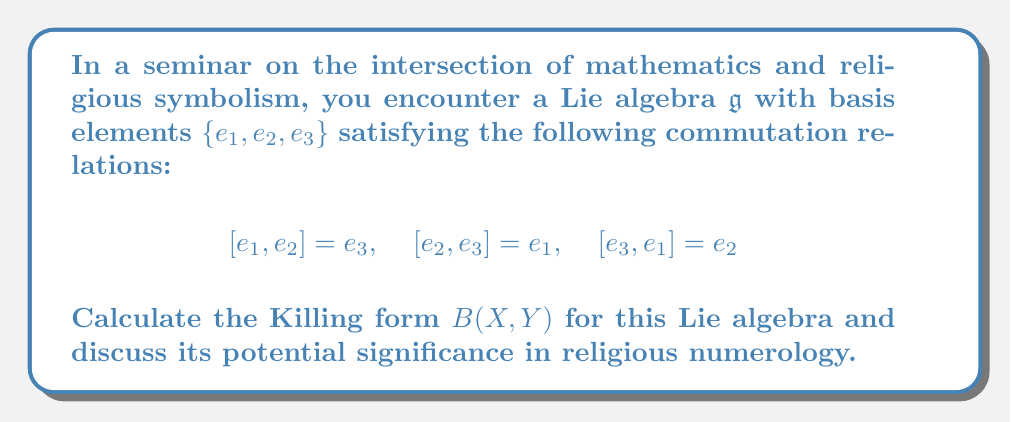Give your solution to this math problem. To calculate the Killing form for this Lie algebra, we follow these steps:

1) The Killing form is defined as $B(X,Y) = \text{tr}(\text{ad}(X) \circ \text{ad}(Y))$, where $\text{ad}(X)$ is the adjoint representation of $X$.

2) First, we need to find the matrix representation of $\text{ad}(e_i)$ for each basis element. We can do this by calculating $[e_i, e_j]$ for all $i,j$:

   $\text{ad}(e_1) = \begin{pmatrix} 0 & 0 & -1 \\ 0 & 0 & 1 \\ 0 & -1 & 0 \end{pmatrix}$

   $\text{ad}(e_2) = \begin{pmatrix} 0 & 0 & 1 \\ 0 & 0 & -1 \\ -1 & 0 & 0 \end{pmatrix}$

   $\text{ad}(e_3) = \begin{pmatrix} 0 & -1 & 0 \\ 1 & 0 & 0 \\ 0 & 0 & 0 \end{pmatrix}$

3) Now, we calculate $B(e_i, e_j)$ for all $i,j$:

   $B(e_1, e_1) = \text{tr}(\text{ad}(e_1) \circ \text{ad}(e_1)) = -2$
   $B(e_2, e_2) = \text{tr}(\text{ad}(e_2) \circ \text{ad}(e_2)) = -2$
   $B(e_3, e_3) = \text{tr}(\text{ad}(e_3) \circ \text{ad}(e_3)) = -2$

   $B(e_1, e_2) = B(e_2, e_1) = \text{tr}(\text{ad}(e_1) \circ \text{ad}(e_2)) = 0$
   $B(e_1, e_3) = B(e_3, e_1) = \text{tr}(\text{ad}(e_1) \circ \text{ad}(e_3)) = 0$
   $B(e_2, e_3) = B(e_3, e_2) = \text{tr}(\text{ad}(e_2) \circ \text{ad}(e_3)) = 0$

4) Therefore, the Killing form can be represented as the matrix:

   $$B = \begin{pmatrix} -2 & 0 & 0 \\ 0 & -2 & 0 \\ 0 & 0 & -2 \end{pmatrix}$$

In religious numerology, the number 3 (dimension of the algebra) and the symmetry of the Killing form might be interpreted as symbols of divine perfection or the Holy Trinity in Christian theology. The negative values on the diagonal (-2) could be seen as representing duality or opposition in religious philosophies.
Answer: The Killing form for the given Lie algebra is:

$$B = \begin{pmatrix} -2 & 0 & 0 \\ 0 & -2 & 0 \\ 0 & 0 & -2 \end{pmatrix}$$ 